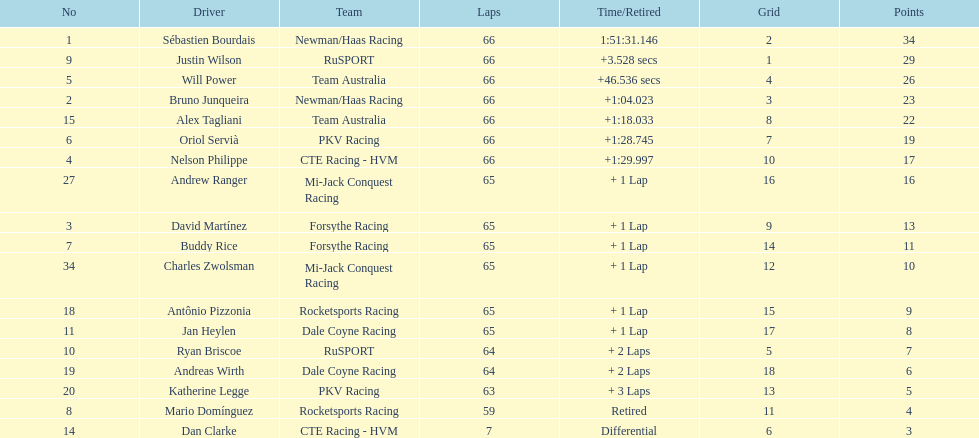Who are the drivers? Sébastien Bourdais, Justin Wilson, Will Power, Bruno Junqueira, Alex Tagliani, Oriol Servià, Nelson Philippe, Andrew Ranger, David Martínez, Buddy Rice, Charles Zwolsman, Antônio Pizzonia, Jan Heylen, Ryan Briscoe, Andreas Wirth, Katherine Legge, Mario Domínguez, Dan Clarke. What are their numbers? 1, 9, 5, 2, 15, 6, 4, 27, 3, 7, 34, 18, 11, 10, 19, 20, 8, 14. What are their positions? 1, 2, 3, 4, 5, 6, 7, 8, 9, 10, 11, 12, 13, 14, 15, 16, 17, 18. Which driver has the same number and position? Sébastien Bourdais. 